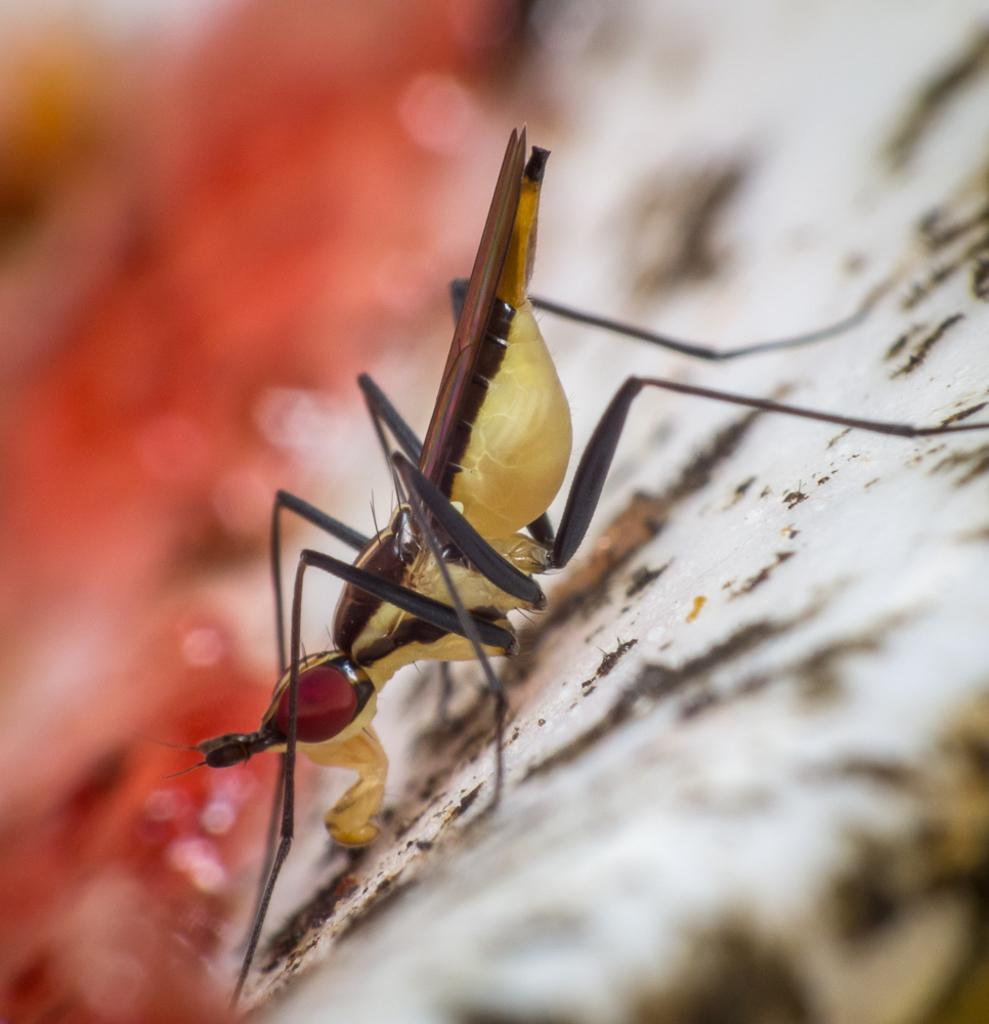What type of creature can be seen in the image? There is an insect in the image. Where is the insect located? The insect is on the ground. Can you describe the background of the image? The background of the image is blurred. How many kittens are playing with the minute in the image? There are no kittens or minutes present in the image; it features an insect on the ground with a blurred background. 